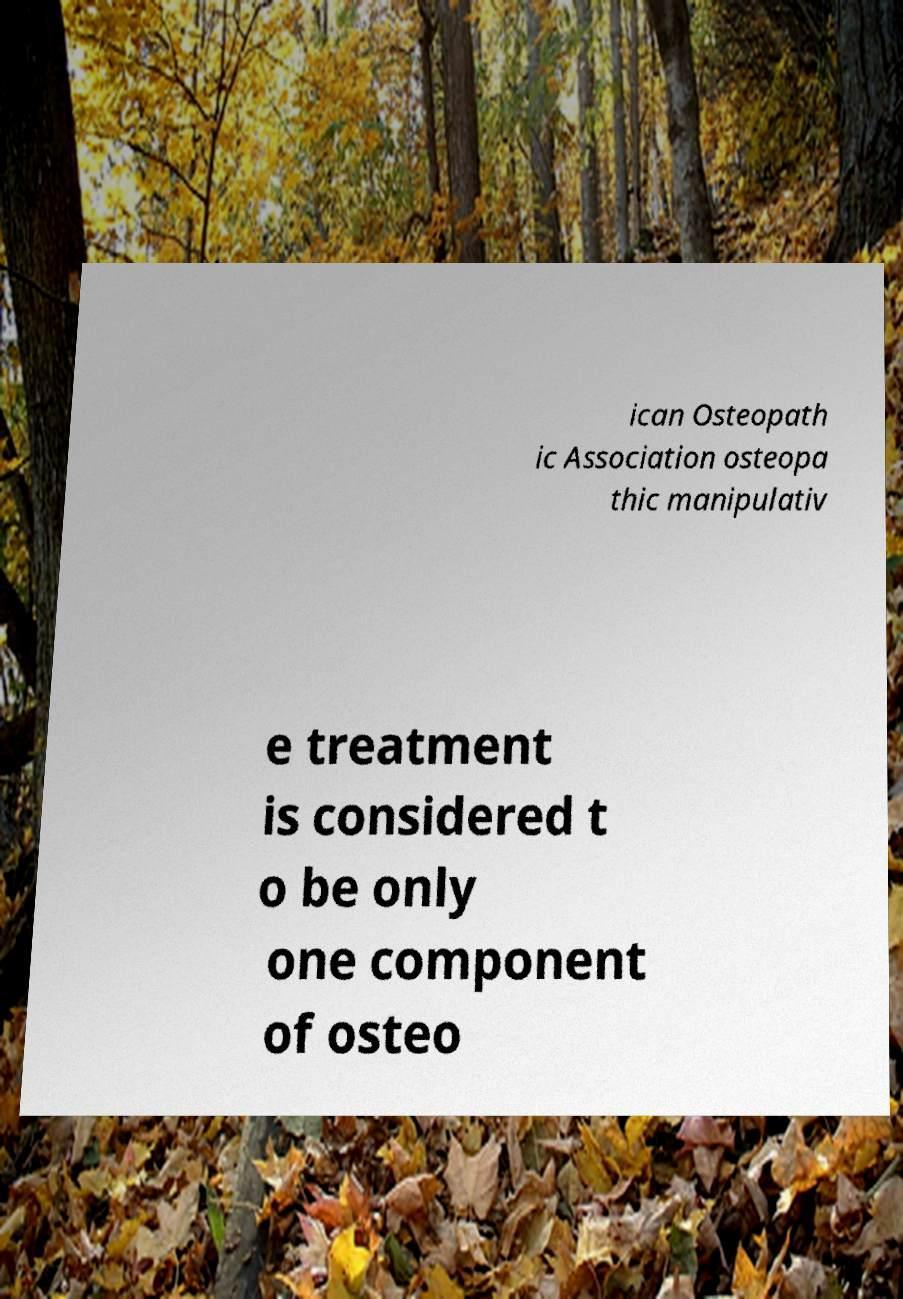What messages or text are displayed in this image? I need them in a readable, typed format. ican Osteopath ic Association osteopa thic manipulativ e treatment is considered t o be only one component of osteo 